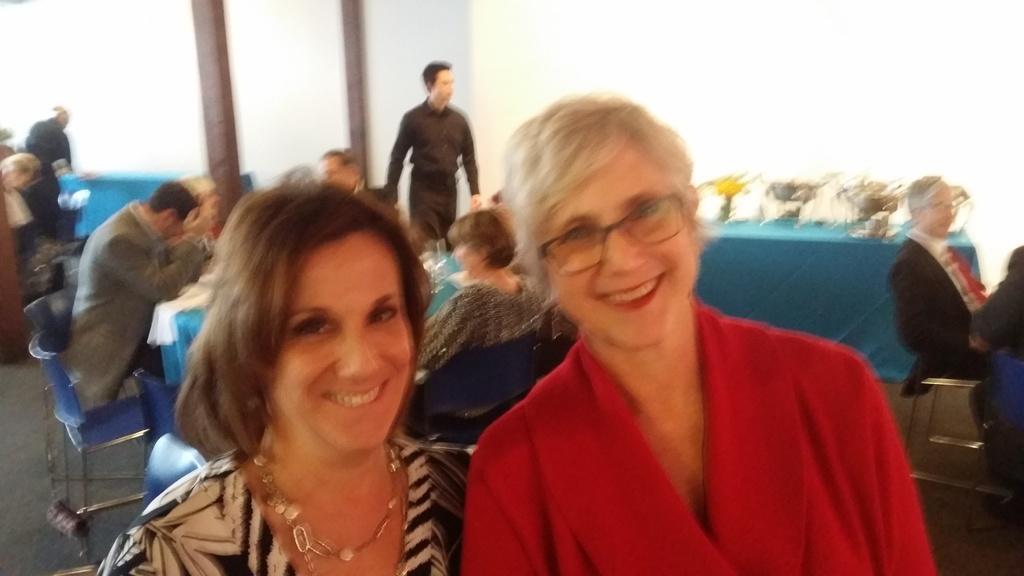Can you describe this image briefly? In this image we can see a few people, among them some people are sitting on the chairs and some people are standing, we can see there are some tables covered with the blue color cloth, on the tables we can see clothes, bowl, flower vase and some other objects. 